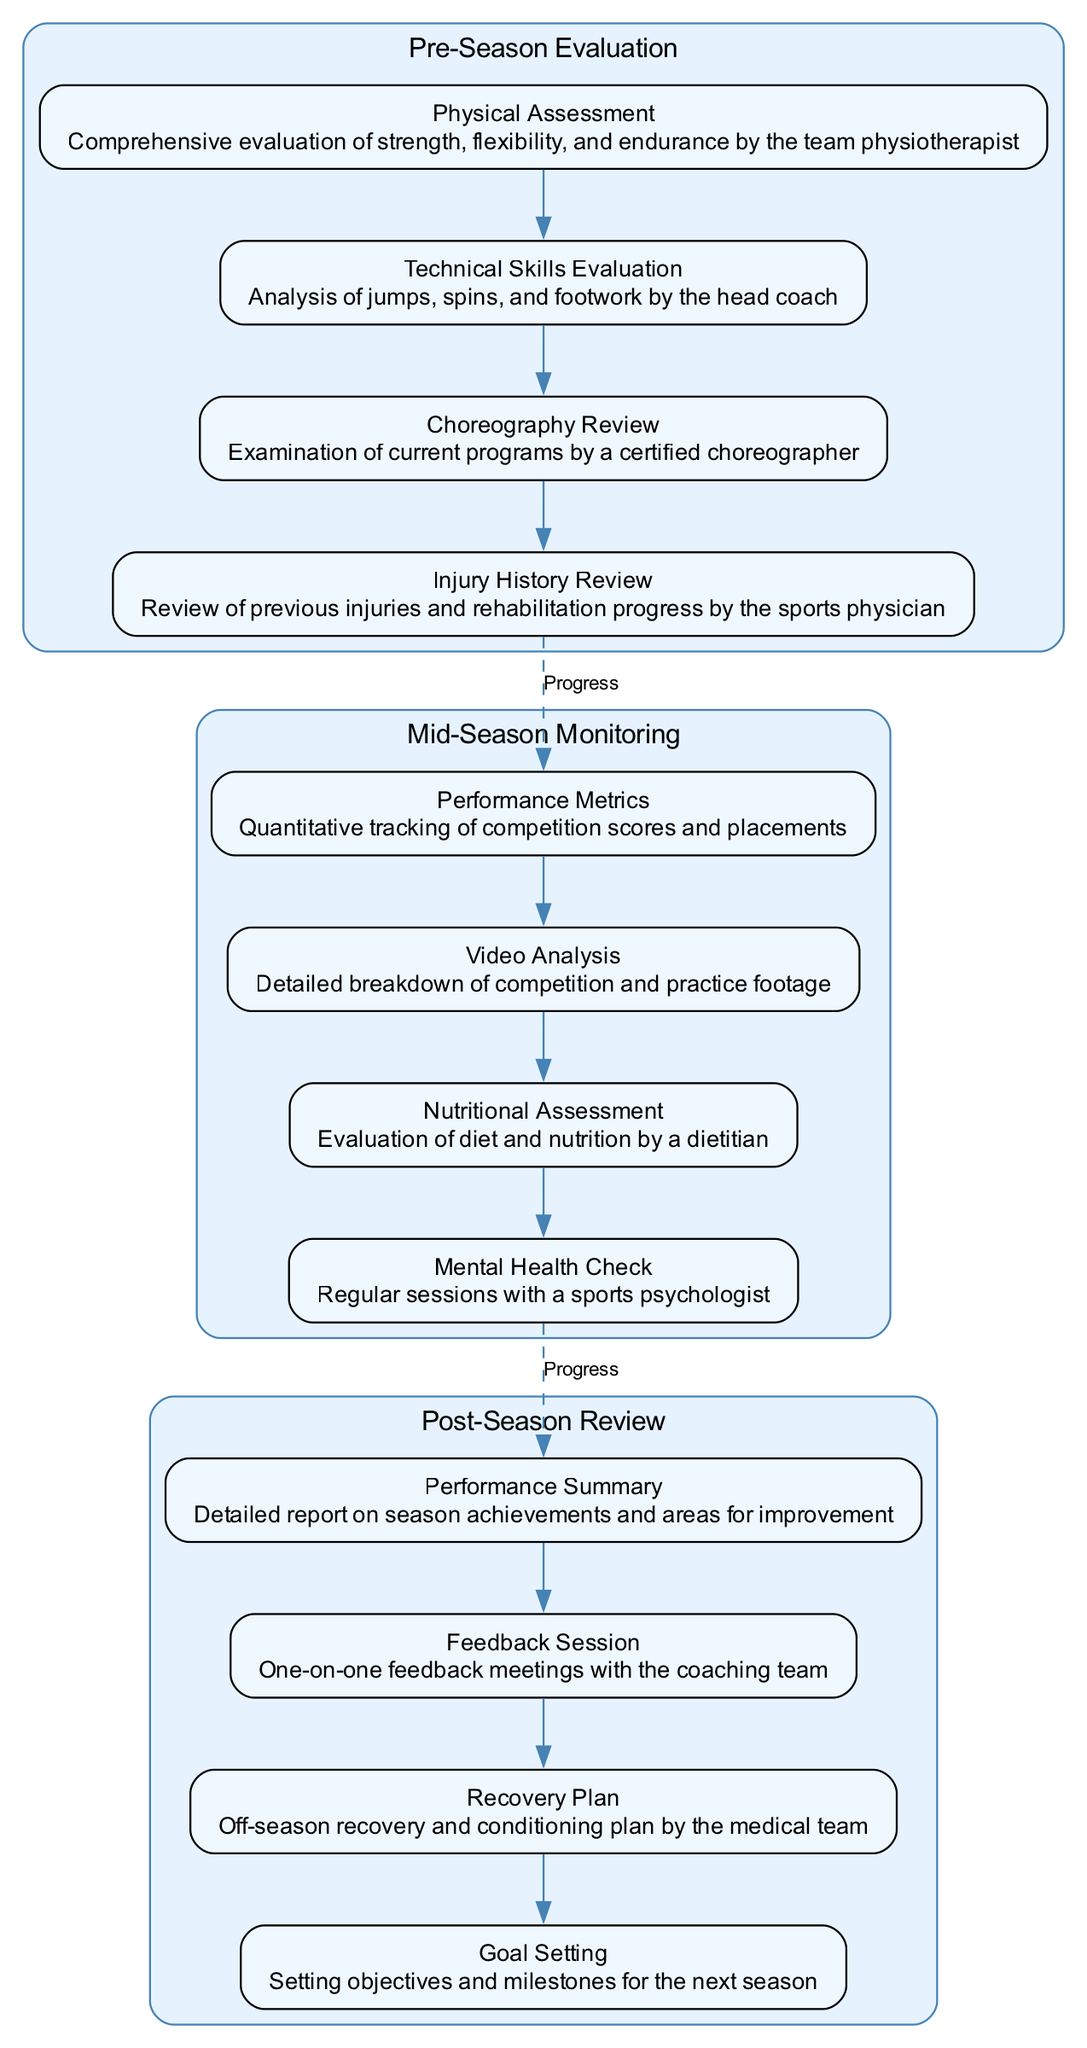What is the first stage in the pathway? The first stage listed in the diagram is "Pre-Season Evaluation." This can be found at the top section of the diagram as it describes the initial evaluation process.
Answer: Pre-Season Evaluation How many components are there in the Mid-Season Monitoring stage? In the Mid-Season Monitoring stage, there are four components listed, which can be seen within the cluster designated for this stage.
Answer: 4 What is the last component of the Post-Season Review? The last component of the Post-Season Review is "Goal Setting," which is the final item presented in the list of components for this stage.
Answer: Goal Setting Which stage includes a "Mental Health Check"? The "Mental Health Check" is included in the Mid-Season Monitoring stage, as indicated in the components listed under that specific stage.
Answer: Mid-Season Monitoring What connects the last component of each stage to the first component of the next stage? The connection is represented by a dashed edge labeled "Progress," linking the last component of one stage to the first component of the subsequent stage.
Answer: Progress How many total stages are present in the diagram? The diagram contains three distinct stages as outlined in the sections that describe the progression of the performance evaluation process.
Answer: 3 What type of assessment is performed by the dietitian? The assessment performed by the dietitian is a "Nutritional Assessment," as described in the components of the Mid-Season Monitoring stage.
Answer: Nutritional Assessment Which component reviews previous injuries? The component that reviews previous injuries is "Injury History Review," found in the Pre-Season Evaluation stage.
Answer: Injury History Review What follows the Technical Skills Evaluation? Following the Technical Skills Evaluation is the "Choreography Review," as it appears next in the sequence of components listed under the Pre-Season Evaluation stage.
Answer: Choreography Review 